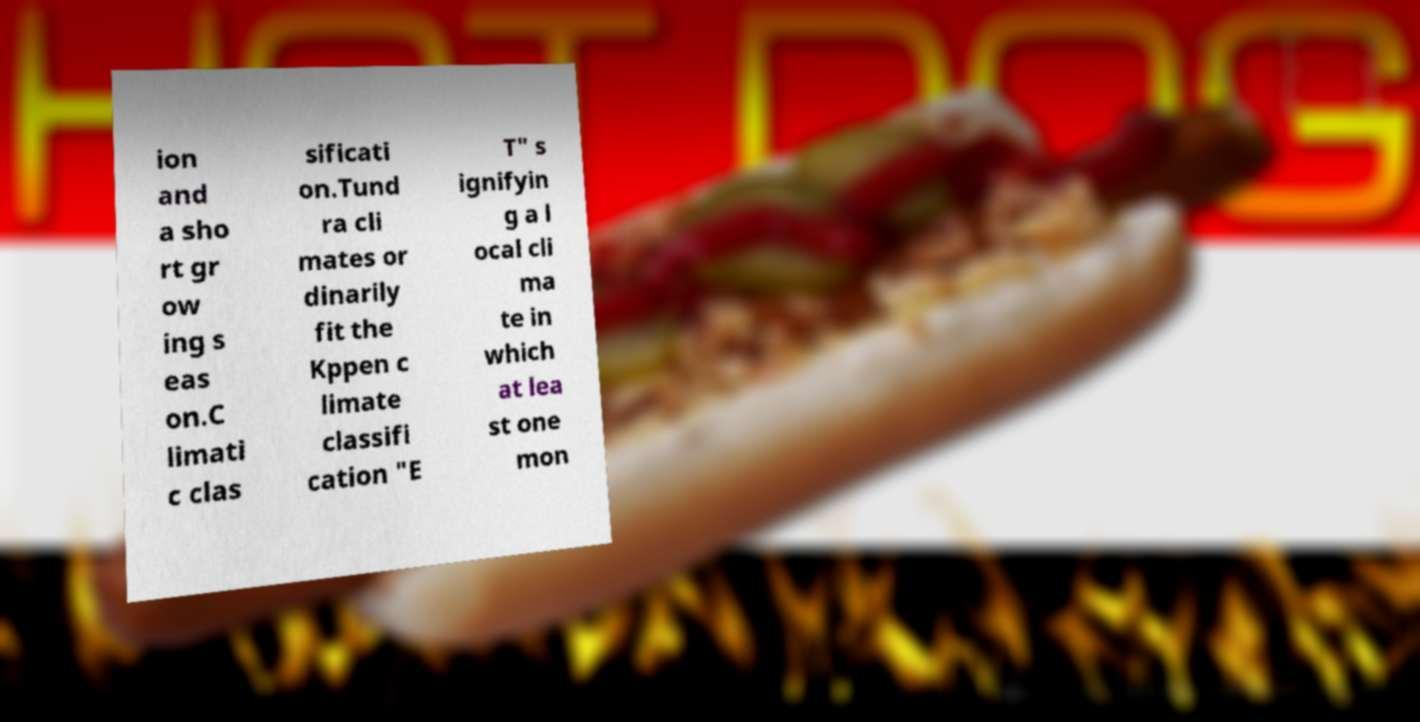Please identify and transcribe the text found in this image. ion and a sho rt gr ow ing s eas on.C limati c clas sificati on.Tund ra cli mates or dinarily fit the Kppen c limate classifi cation "E T" s ignifyin g a l ocal cli ma te in which at lea st one mon 